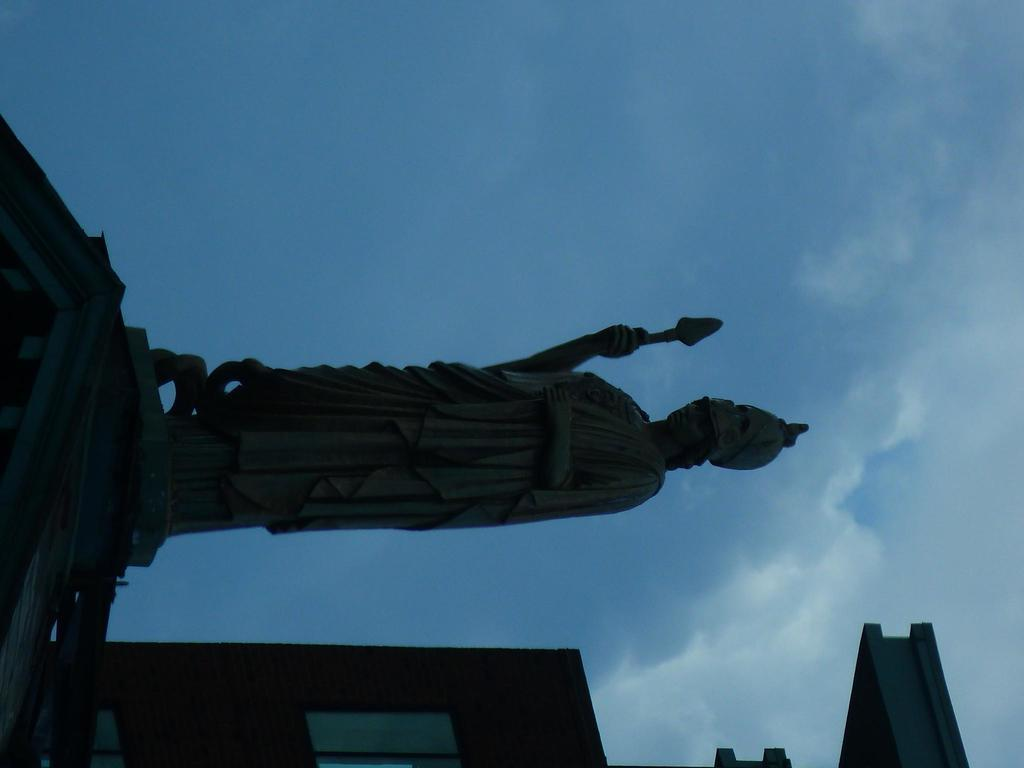What is the main subject of the image? There is a statue in the image. How is the statue positioned in relation to other elements in the image? The statue is in front of other elements. What can be seen behind the statue? There is a building behind the statue. What is visible in the background of the image? The sky is visible in the background of the image. How much debt is the statue incurring in the image? There is no indication of debt in the image, as it features a statue and other elements. Can you see any bees buzzing around the statue in the image? There are no bees visible in the image; it only features a statue, a building, and the sky. 